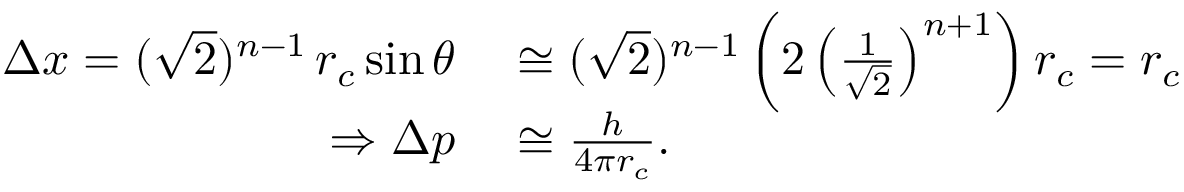<formula> <loc_0><loc_0><loc_500><loc_500>\begin{array} { r l } { \Delta x = ( \sqrt { 2 } ) ^ { n - 1 } \, r _ { c } \sin \theta } & \cong ( \sqrt { 2 } ) ^ { n - 1 } \left ( 2 \left ( \frac { 1 } { \sqrt { 2 } } \right ) ^ { n + 1 } \right ) r _ { c } = r _ { c } } \\ { \Rightarrow \Delta p } & \cong \frac { h } { 4 \pi r _ { c } } . } \end{array}</formula> 